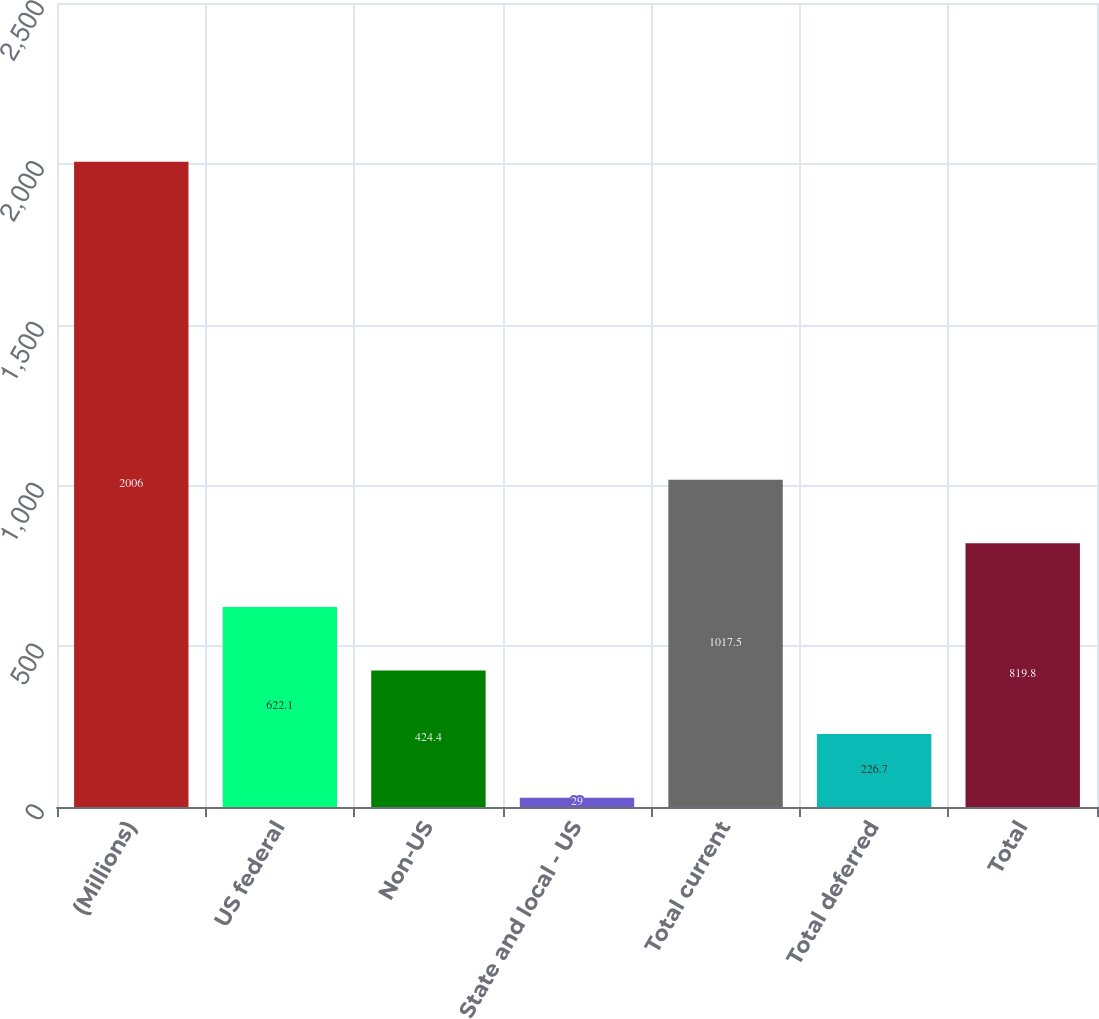<chart> <loc_0><loc_0><loc_500><loc_500><bar_chart><fcel>(Millions)<fcel>US federal<fcel>Non-US<fcel>State and local - US<fcel>Total current<fcel>Total deferred<fcel>Total<nl><fcel>2006<fcel>622.1<fcel>424.4<fcel>29<fcel>1017.5<fcel>226.7<fcel>819.8<nl></chart> 